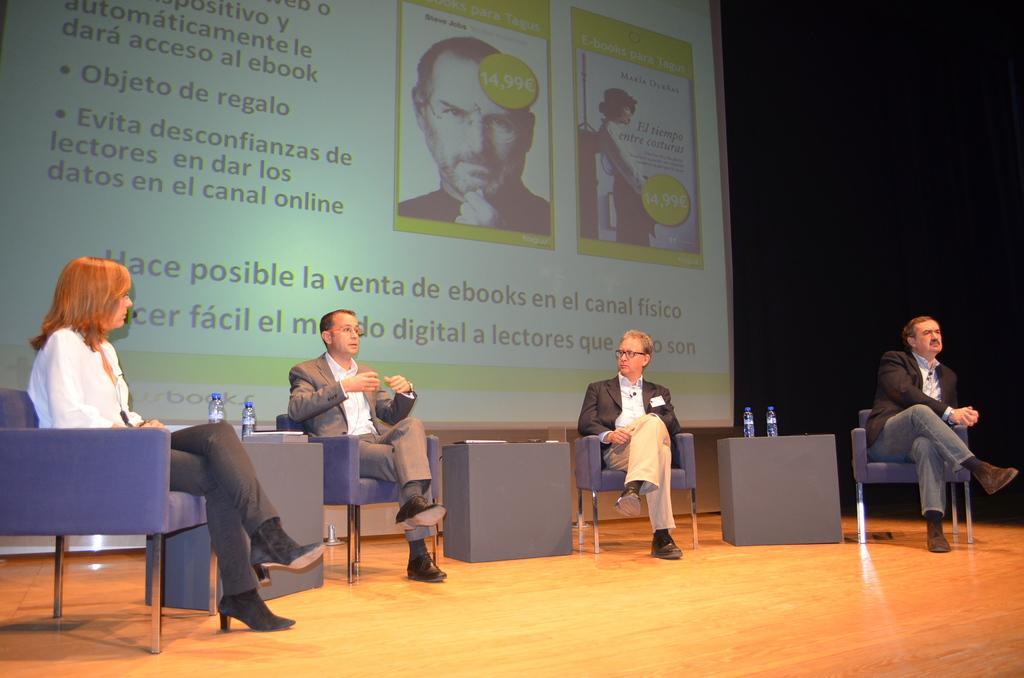Can you describe this image briefly? As we can see in the image there is a banner, few people sitting on chairs and there are bottles. 